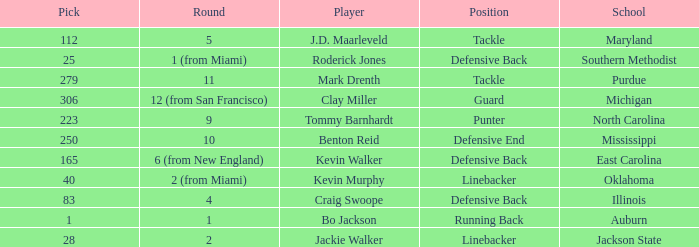Give me the full table as a dictionary. {'header': ['Pick', 'Round', 'Player', 'Position', 'School'], 'rows': [['112', '5', 'J.D. Maarleveld', 'Tackle', 'Maryland'], ['25', '1 (from Miami)', 'Roderick Jones', 'Defensive Back', 'Southern Methodist'], ['279', '11', 'Mark Drenth', 'Tackle', 'Purdue'], ['306', '12 (from San Francisco)', 'Clay Miller', 'Guard', 'Michigan'], ['223', '9', 'Tommy Barnhardt', 'Punter', 'North Carolina'], ['250', '10', 'Benton Reid', 'Defensive End', 'Mississippi'], ['165', '6 (from New England)', 'Kevin Walker', 'Defensive Back', 'East Carolina'], ['40', '2 (from Miami)', 'Kevin Murphy', 'Linebacker', 'Oklahoma'], ['83', '4', 'Craig Swoope', 'Defensive Back', 'Illinois'], ['1', '1', 'Bo Jackson', 'Running Back', 'Auburn'], ['28', '2', 'Jackie Walker', 'Linebacker', 'Jackson State']]} What school did bo jackson attend? Auburn. 